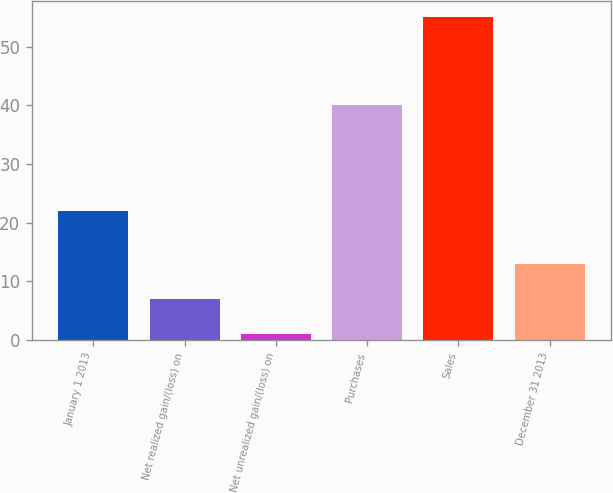<chart> <loc_0><loc_0><loc_500><loc_500><bar_chart><fcel>January 1 2013<fcel>Net realized gain/(loss) on<fcel>Net unrealized gain/(loss) on<fcel>Purchases<fcel>Sales<fcel>December 31 2013<nl><fcel>22<fcel>7<fcel>1<fcel>40<fcel>55<fcel>13<nl></chart> 